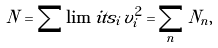<formula> <loc_0><loc_0><loc_500><loc_500>N = \sum \lim i t s _ { i } \, v _ { i } ^ { 2 } = \sum _ { n } N _ { n } ,</formula> 